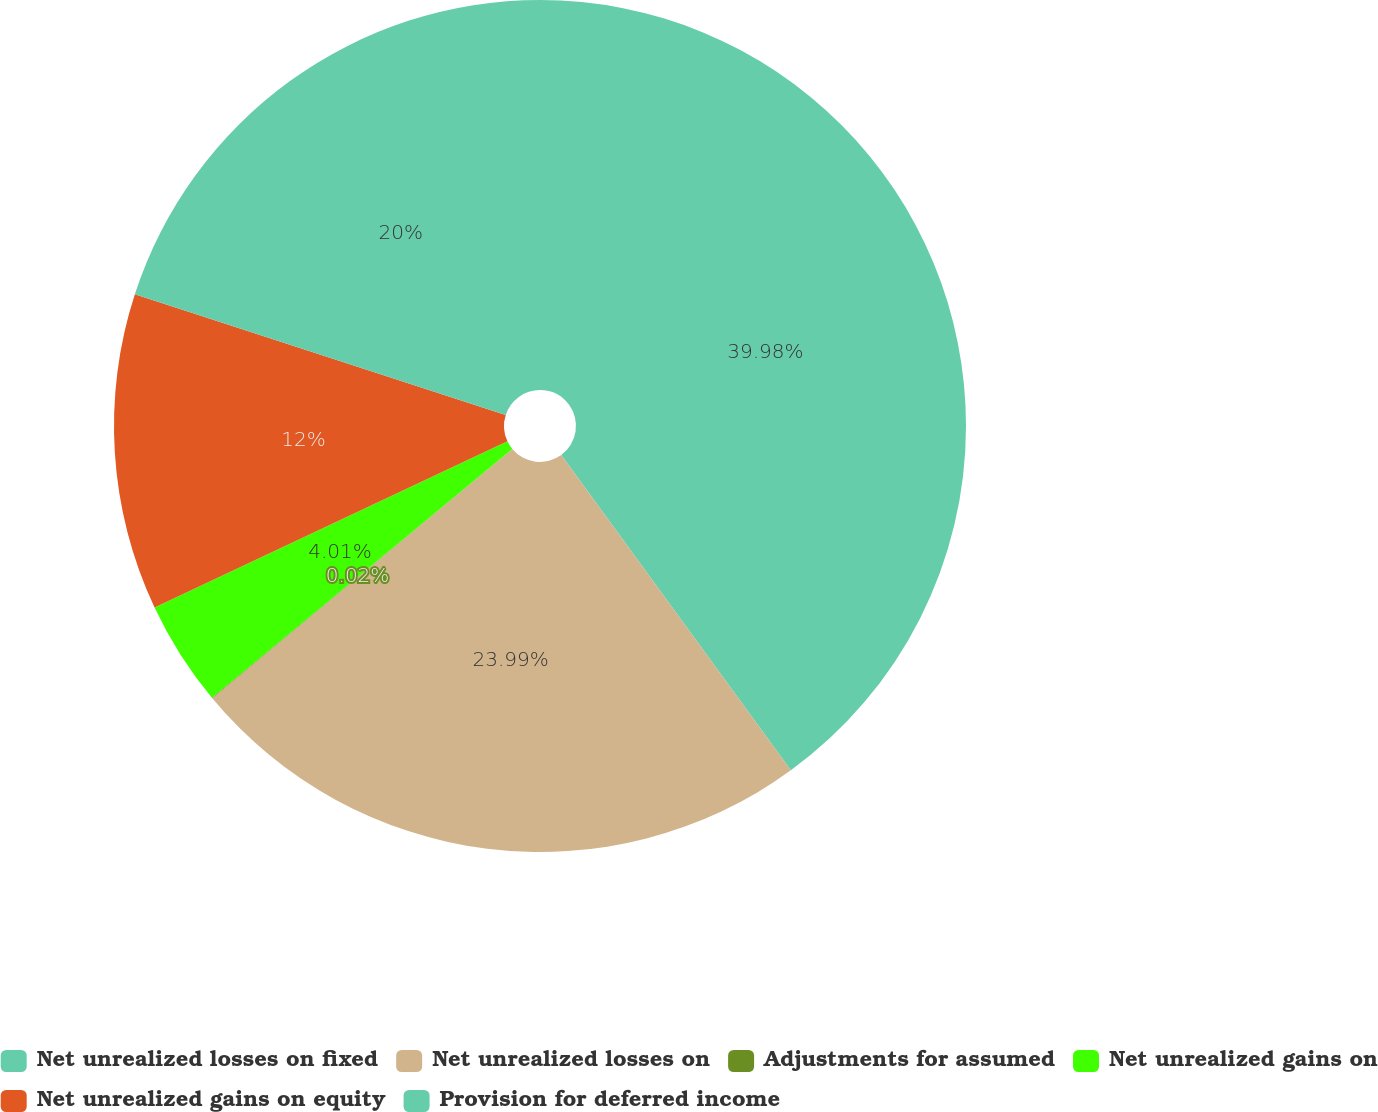<chart> <loc_0><loc_0><loc_500><loc_500><pie_chart><fcel>Net unrealized losses on fixed<fcel>Net unrealized losses on<fcel>Adjustments for assumed<fcel>Net unrealized gains on<fcel>Net unrealized gains on equity<fcel>Provision for deferred income<nl><fcel>39.98%<fcel>23.99%<fcel>0.02%<fcel>4.01%<fcel>12.0%<fcel>20.0%<nl></chart> 